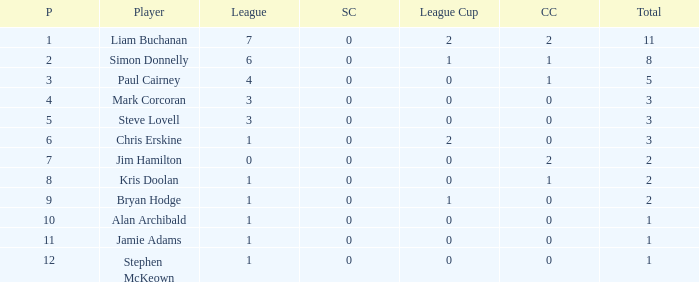What is bryan hodge's player number 1.0. 